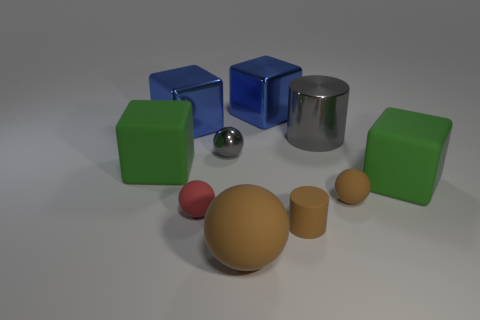Are any small matte blocks visible?
Give a very brief answer. No. The gray thing that is the same material as the large gray cylinder is what size?
Provide a short and direct response. Small. Are the red ball and the brown cylinder made of the same material?
Provide a short and direct response. Yes. How many other things are there of the same material as the large gray thing?
Provide a succinct answer. 3. How many things are on the left side of the tiny cylinder and behind the matte cylinder?
Give a very brief answer. 5. The shiny ball has what color?
Your answer should be very brief. Gray. What material is the other big thing that is the same shape as the red matte object?
Offer a terse response. Rubber. Is there anything else that is the same material as the tiny gray object?
Your answer should be very brief. Yes. Is the color of the big metallic cylinder the same as the matte cylinder?
Ensure brevity in your answer.  No. The large object in front of the tiny ball on the right side of the tiny gray ball is what shape?
Ensure brevity in your answer.  Sphere. 